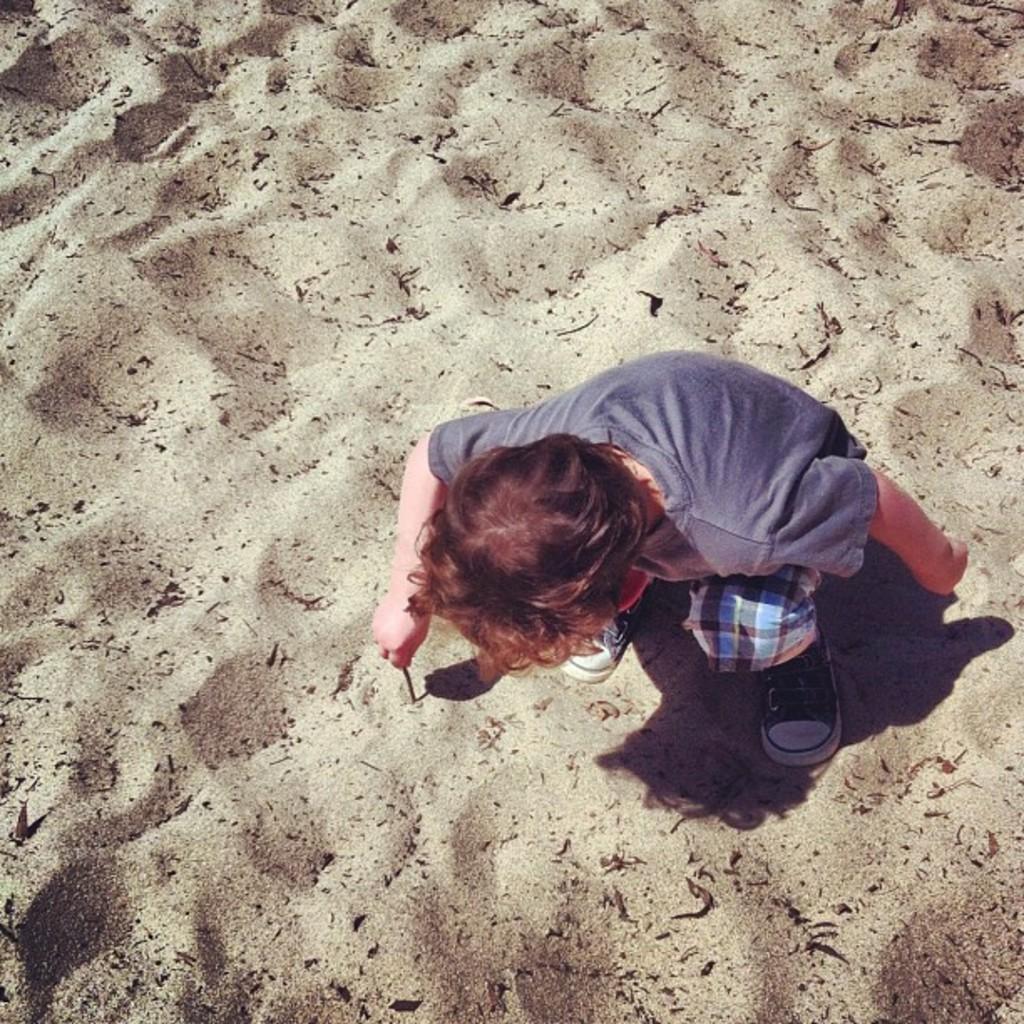Could you give a brief overview of what you see in this image? In this image we can see a boy and sand. The boy is wearing a T-shirt, pant, shoes and holding wooden stick in his hand. 